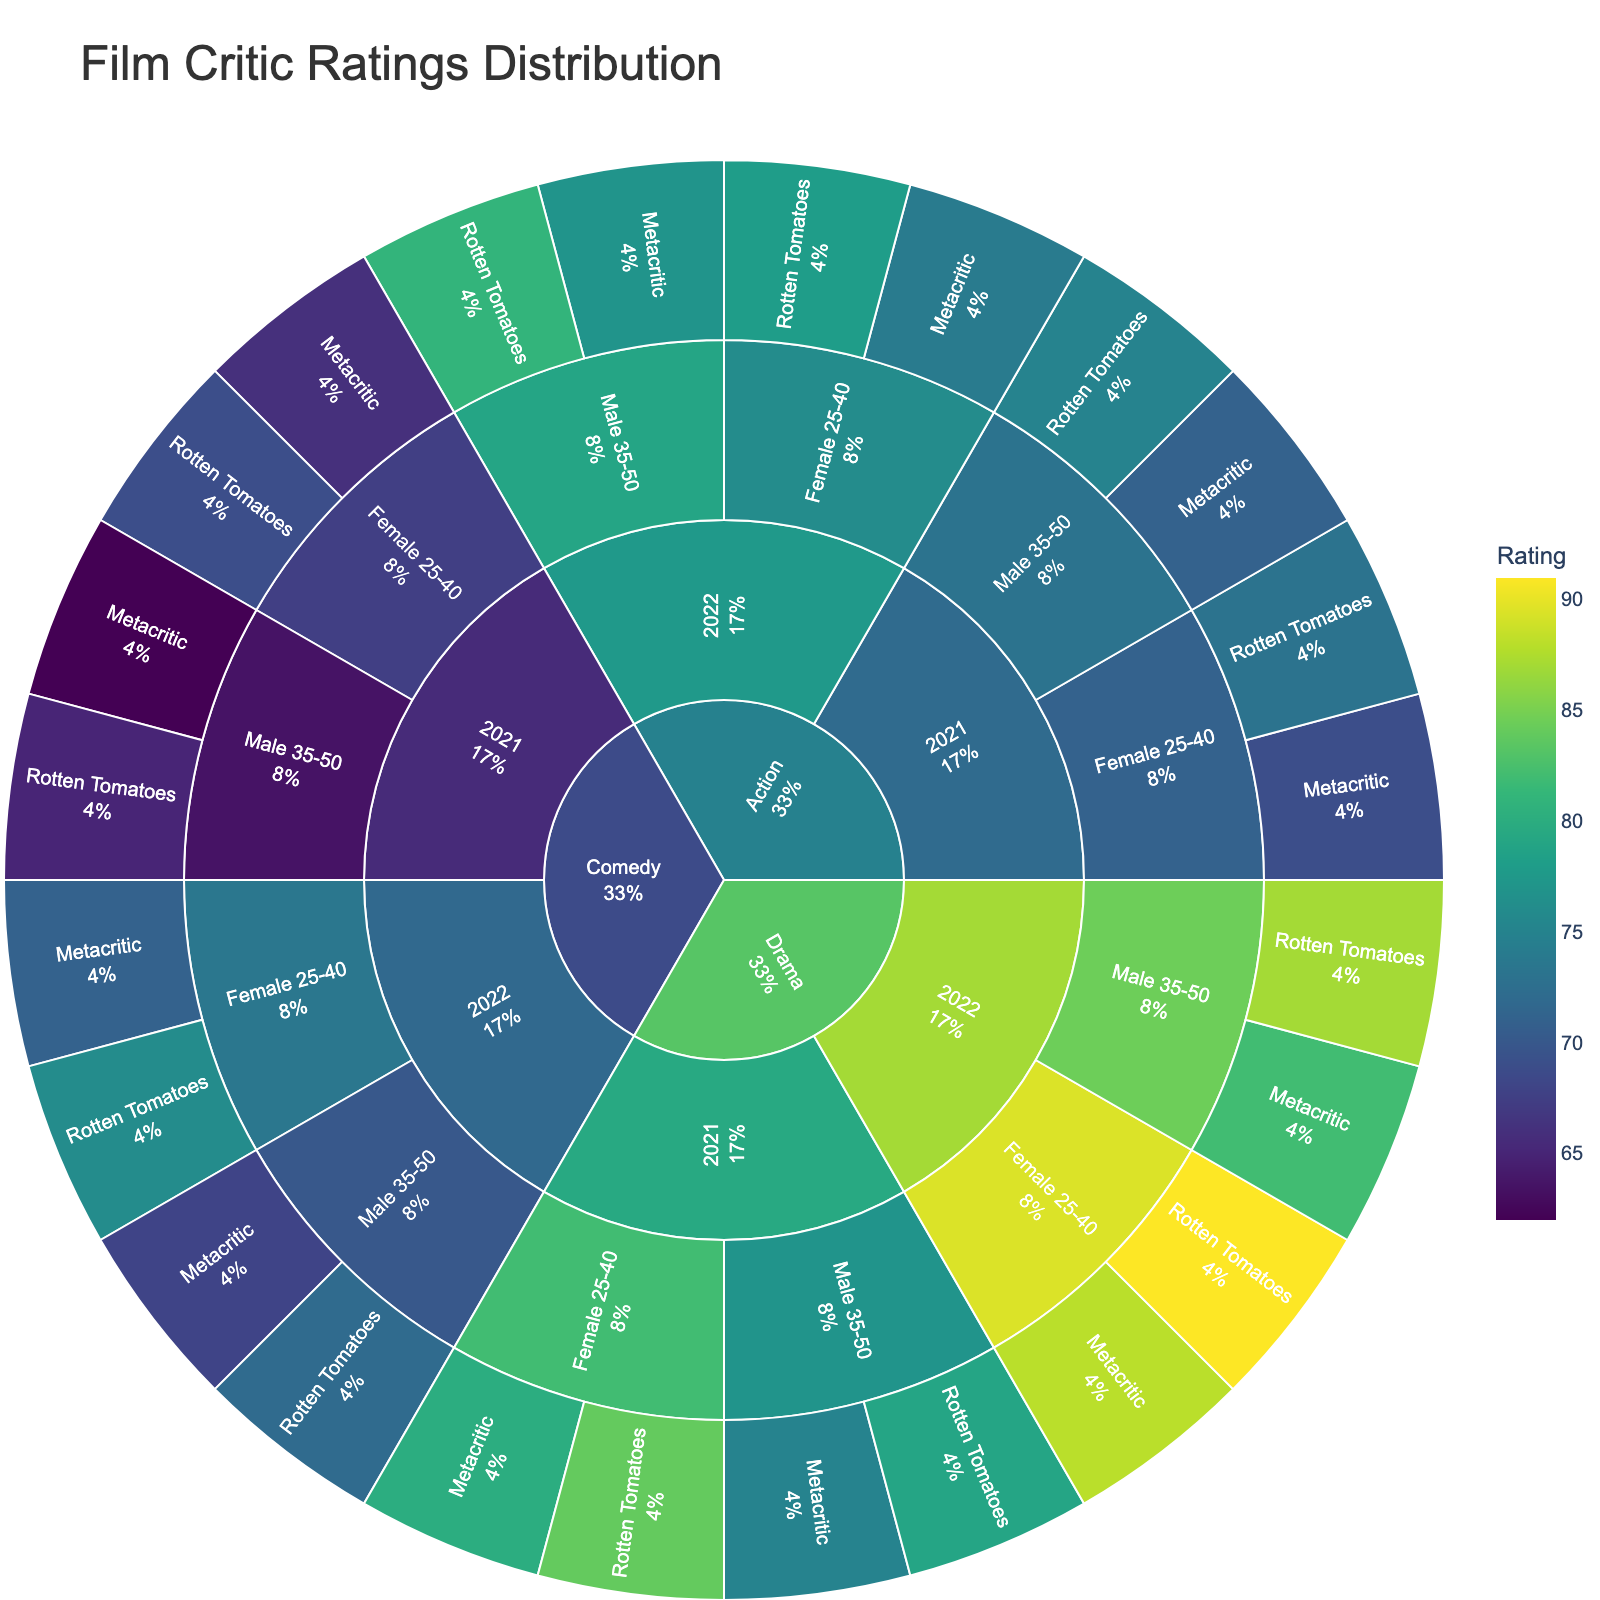What's the title of the plot? The title of the plot is usually displayed at the top center of the figure.
Answer: Film Critic Ratings Distribution Which genre received the highest ratings in 2022 by Female critics aged 25-40 on Rotten Tomatoes? To find this, look under the 'Drama' genre, then '2022', 'Female 25-40', and 'Rotten Tomatoes'. Observe the rating in the hover data.
Answer: Drama How do the ratings of 'Action' movies in 2021 compare between Metacritic and Rotten Tomatoes for Male critics aged 35-50? Check the ratings under 'Action', then '2021', 'Male 35-50', and compare the values in 'Rotten Tomatoes' and 'Metacritic'.
Answer: 75 on Rotten Tomatoes, 71 on Metacritic What is the difference in ratings given by Female critics aged 25-40 between 'Drama' and 'Comedy' in 2022 on Metacritic? Find ratings for 'Drama', and 'Comedy' for '2022', 'Female 25-40', and 'Metacritic'. Subtract the Comedy rating from the Drama rating.
Answer: 17 Which year and critic demographic received the highest aggregated rating for 'Comedy' movies across both platforms? Navigate 'Comedy' genre, then look at each year and critic demographic node to see the highest individual ratings in hover data from either platform.
Answer: 2022 Female 25-40 Between 2021 and 2022, which year had higher average ratings from Male critics aged 35-50 for 'Drama' movies across both platforms? Find and sum the ratings for 'Drama', 'Male 35-50' in 2021 and 2022 across both platforms. Average the ratings for each year and compare them. 
For 2021: (79 + 75) / 2 = 77
For 2022: (87 + 82) / 2 = 84.5
Answer: 2022 What percentage of the total ratings were from Male critics aged 35-50 for 'Comedy' movies in 2021 on Rotten Tomatoes? Locate 'Comedy', '2021', 'Male 35-50', 'Rotten Tomatoes' and look for its percentage as displayed in the sunburst plot section.
Answer: Displayed in the figure Which critic demographic rated 'Action' movies higher in 2021 on Rotten Tomatoes: Male 35-50 or Female 25-40? Check 'Action', '2021', for both 'Male 35-50' and 'Female 25-40' under 'Rotten Tomatoes'. Compare their ratings in hover data.
Answer: Male 35-50 